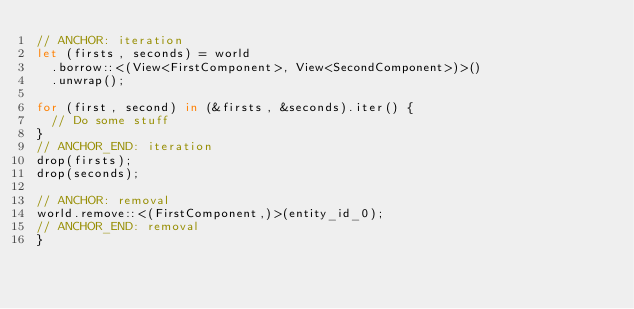<code> <loc_0><loc_0><loc_500><loc_500><_Rust_>// ANCHOR: iteration
let (firsts, seconds) = world
	.borrow::<(View<FirstComponent>, View<SecondComponent>)>()
	.unwrap();

for (first, second) in (&firsts, &seconds).iter() {
	// Do some stuff
}
// ANCHOR_END: iteration
drop(firsts);
drop(seconds);

// ANCHOR: removal
world.remove::<(FirstComponent,)>(entity_id_0);
// ANCHOR_END: removal
}
</code> 